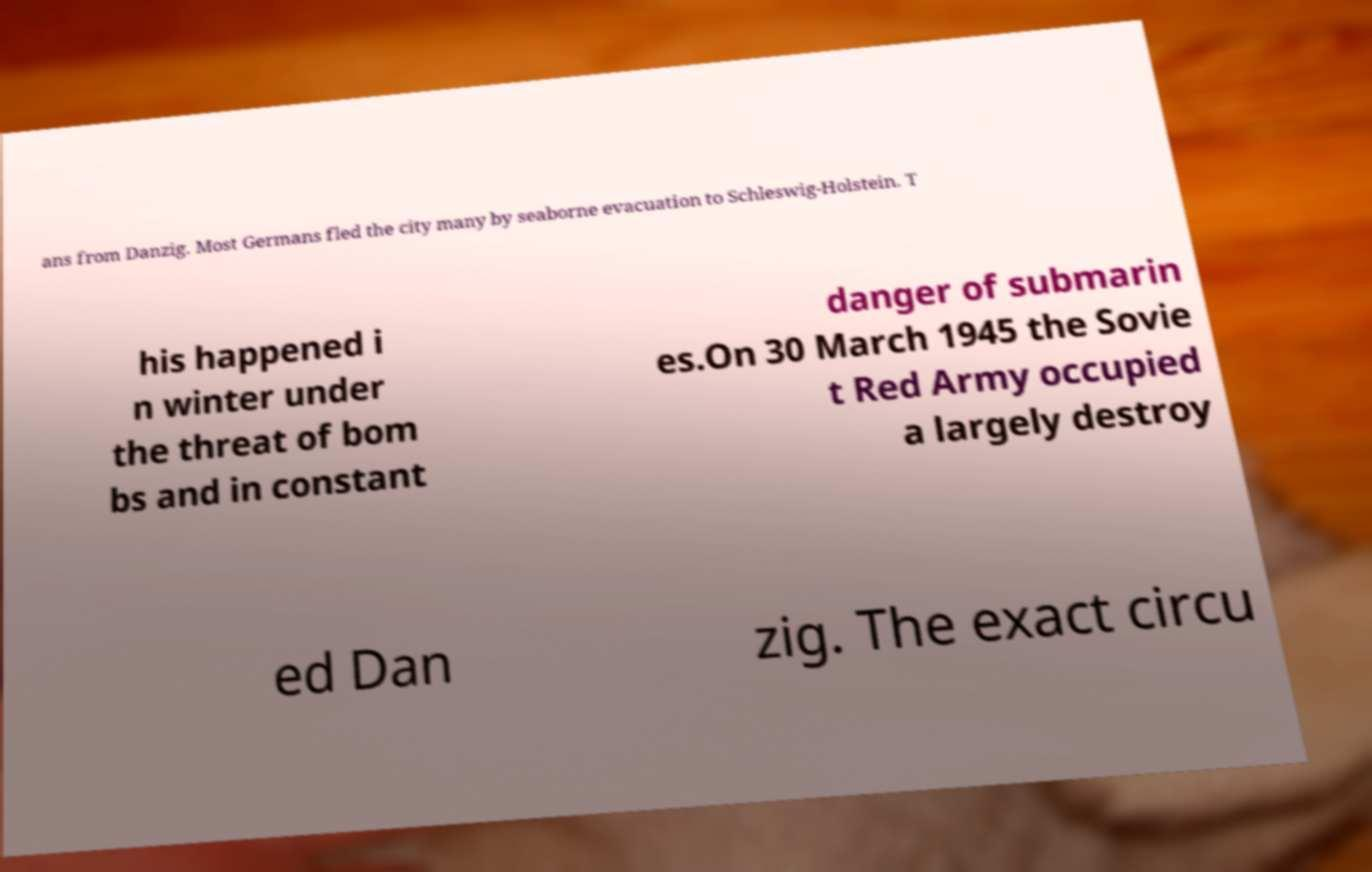Could you assist in decoding the text presented in this image and type it out clearly? ans from Danzig. Most Germans fled the city many by seaborne evacuation to Schleswig-Holstein. T his happened i n winter under the threat of bom bs and in constant danger of submarin es.On 30 March 1945 the Sovie t Red Army occupied a largely destroy ed Dan zig. The exact circu 